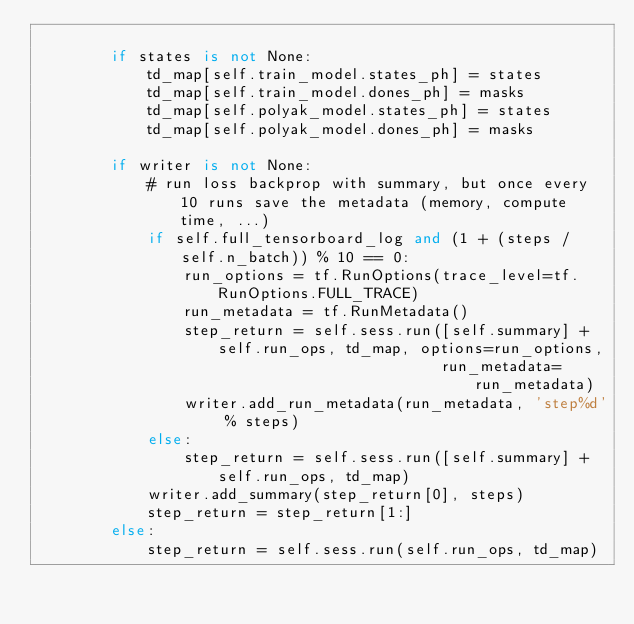Convert code to text. <code><loc_0><loc_0><loc_500><loc_500><_Python_>
        if states is not None:
            td_map[self.train_model.states_ph] = states
            td_map[self.train_model.dones_ph] = masks
            td_map[self.polyak_model.states_ph] = states
            td_map[self.polyak_model.dones_ph] = masks

        if writer is not None:
            # run loss backprop with summary, but once every 10 runs save the metadata (memory, compute time, ...)
            if self.full_tensorboard_log and (1 + (steps / self.n_batch)) % 10 == 0:
                run_options = tf.RunOptions(trace_level=tf.RunOptions.FULL_TRACE)
                run_metadata = tf.RunMetadata()
                step_return = self.sess.run([self.summary] + self.run_ops, td_map, options=run_options,
                                            run_metadata=run_metadata)
                writer.add_run_metadata(run_metadata, 'step%d' % steps)
            else:
                step_return = self.sess.run([self.summary] + self.run_ops, td_map)
            writer.add_summary(step_return[0], steps)
            step_return = step_return[1:]
        else:
            step_return = self.sess.run(self.run_ops, td_map)
</code> 